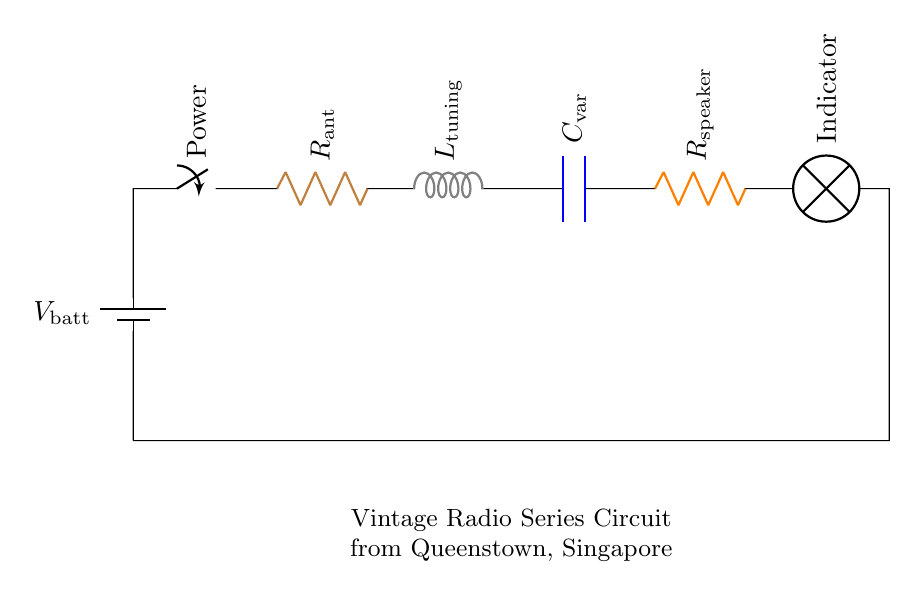What is the total number of components in the circuit? The circuit diagram displays six distinct components: a battery, switch, two resistors, one inductor, one capacitor, and one lamp. Count all these components to arrive at the total.
Answer: six What is the function of the inductor in this circuit? The inductor, labeled as L_tuning, is used for tuning the radio to different frequencies, which allows the user to select specific radio stations. It works in conjunction with the capacitor to form a resonant circuit.
Answer: tuning What type of circuit is represented in the diagram? The diagram represents a series circuit, where all the components are connected in a single loop, allowing current to flow through each one in sequence. This can be confirmed by tracing the connections from the battery back to the battery.
Answer: series What happens to the current if the switch is turned off? When the switch is turned off, it breaks the circuit, causing the current to stop flowing entirely, meaning no current passes through any of the components. Thus, the circuit will not work.
Answer: stops How do R_ant and R_speaker affect the overall resistance of the circuit? In a series circuit, the total resistance is the sum of the individual resistances. Therefore, R_ant (the antenna resistor) and R_speaker (the speaker resistor) would be added together to find the total resistance in the circuit. This affects how much current can flow based on Ohm's law.
Answer: added What does the indicator lamp signify in the circuit? The indicator lamp serves as a visual cue that the circuit is powered on and functioning correctly. When current flows through the circuit, the lamp lights up, indicating operational status.
Answer: powered 